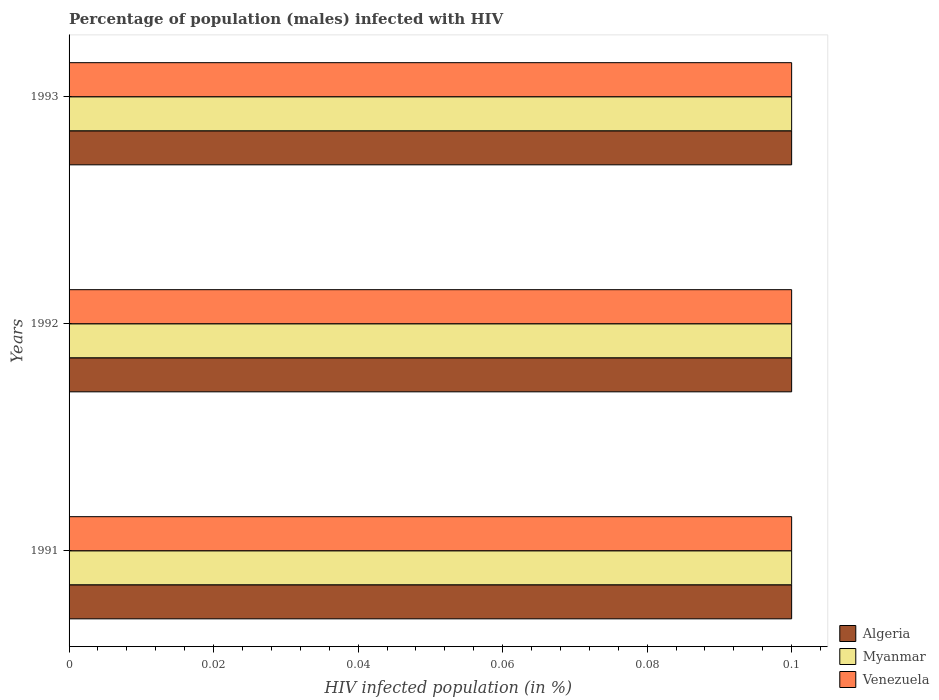How many groups of bars are there?
Your response must be concise. 3. How many bars are there on the 2nd tick from the top?
Provide a short and direct response. 3. How many bars are there on the 3rd tick from the bottom?
Give a very brief answer. 3. What is the percentage of HIV infected male population in Algeria in 1993?
Provide a succinct answer. 0.1. Across all years, what is the maximum percentage of HIV infected male population in Myanmar?
Offer a very short reply. 0.1. Across all years, what is the minimum percentage of HIV infected male population in Venezuela?
Offer a very short reply. 0.1. In which year was the percentage of HIV infected male population in Myanmar minimum?
Provide a short and direct response. 1991. What is the total percentage of HIV infected male population in Venezuela in the graph?
Offer a terse response. 0.3. What is the difference between the percentage of HIV infected male population in Myanmar in 1991 and that in 1993?
Offer a terse response. 0. What is the average percentage of HIV infected male population in Algeria per year?
Offer a terse response. 0.1. In the year 1992, what is the difference between the percentage of HIV infected male population in Myanmar and percentage of HIV infected male population in Algeria?
Provide a short and direct response. 0. In how many years, is the percentage of HIV infected male population in Algeria greater than 0.076 %?
Provide a short and direct response. 3. What is the ratio of the percentage of HIV infected male population in Venezuela in 1991 to that in 1993?
Make the answer very short. 1. What is the difference between the highest and the lowest percentage of HIV infected male population in Venezuela?
Give a very brief answer. 0. In how many years, is the percentage of HIV infected male population in Venezuela greater than the average percentage of HIV infected male population in Venezuela taken over all years?
Provide a short and direct response. 0. What does the 3rd bar from the top in 1993 represents?
Provide a short and direct response. Algeria. What does the 1st bar from the bottom in 1991 represents?
Offer a very short reply. Algeria. Is it the case that in every year, the sum of the percentage of HIV infected male population in Myanmar and percentage of HIV infected male population in Venezuela is greater than the percentage of HIV infected male population in Algeria?
Offer a very short reply. Yes. How many bars are there?
Give a very brief answer. 9. How many years are there in the graph?
Make the answer very short. 3. What is the difference between two consecutive major ticks on the X-axis?
Keep it short and to the point. 0.02. Where does the legend appear in the graph?
Give a very brief answer. Bottom right. How are the legend labels stacked?
Offer a terse response. Vertical. What is the title of the graph?
Your answer should be very brief. Percentage of population (males) infected with HIV. Does "Pacific island small states" appear as one of the legend labels in the graph?
Your answer should be compact. No. What is the label or title of the X-axis?
Your answer should be compact. HIV infected population (in %). What is the label or title of the Y-axis?
Provide a short and direct response. Years. What is the HIV infected population (in %) in Myanmar in 1991?
Provide a succinct answer. 0.1. What is the HIV infected population (in %) of Venezuela in 1991?
Your answer should be compact. 0.1. What is the HIV infected population (in %) in Algeria in 1992?
Make the answer very short. 0.1. What is the HIV infected population (in %) of Myanmar in 1992?
Your response must be concise. 0.1. What is the HIV infected population (in %) of Venezuela in 1992?
Ensure brevity in your answer.  0.1. What is the HIV infected population (in %) in Venezuela in 1993?
Give a very brief answer. 0.1. Across all years, what is the maximum HIV infected population (in %) of Venezuela?
Offer a very short reply. 0.1. Across all years, what is the minimum HIV infected population (in %) in Algeria?
Your answer should be very brief. 0.1. Across all years, what is the minimum HIV infected population (in %) of Venezuela?
Your answer should be very brief. 0.1. What is the total HIV infected population (in %) of Myanmar in the graph?
Your response must be concise. 0.3. What is the total HIV infected population (in %) of Venezuela in the graph?
Provide a succinct answer. 0.3. What is the difference between the HIV infected population (in %) in Myanmar in 1991 and that in 1992?
Your answer should be compact. 0. What is the difference between the HIV infected population (in %) of Venezuela in 1991 and that in 1992?
Offer a very short reply. 0. What is the difference between the HIV infected population (in %) in Myanmar in 1991 and that in 1993?
Provide a succinct answer. 0. What is the difference between the HIV infected population (in %) of Myanmar in 1992 and that in 1993?
Your answer should be very brief. 0. What is the difference between the HIV infected population (in %) of Algeria in 1991 and the HIV infected population (in %) of Venezuela in 1992?
Your answer should be very brief. 0. What is the difference between the HIV infected population (in %) of Myanmar in 1991 and the HIV infected population (in %) of Venezuela in 1992?
Keep it short and to the point. 0. What is the difference between the HIV infected population (in %) of Algeria in 1992 and the HIV infected population (in %) of Myanmar in 1993?
Your response must be concise. 0. What is the difference between the HIV infected population (in %) of Algeria in 1992 and the HIV infected population (in %) of Venezuela in 1993?
Your response must be concise. 0. What is the average HIV infected population (in %) of Venezuela per year?
Your answer should be compact. 0.1. In the year 1991, what is the difference between the HIV infected population (in %) in Algeria and HIV infected population (in %) in Venezuela?
Make the answer very short. 0. In the year 1991, what is the difference between the HIV infected population (in %) of Myanmar and HIV infected population (in %) of Venezuela?
Ensure brevity in your answer.  0. In the year 1992, what is the difference between the HIV infected population (in %) in Algeria and HIV infected population (in %) in Venezuela?
Give a very brief answer. 0. In the year 1993, what is the difference between the HIV infected population (in %) in Algeria and HIV infected population (in %) in Myanmar?
Your response must be concise. 0. In the year 1993, what is the difference between the HIV infected population (in %) in Algeria and HIV infected population (in %) in Venezuela?
Offer a terse response. 0. In the year 1993, what is the difference between the HIV infected population (in %) in Myanmar and HIV infected population (in %) in Venezuela?
Keep it short and to the point. 0. What is the ratio of the HIV infected population (in %) of Algeria in 1991 to that in 1992?
Provide a succinct answer. 1. What is the ratio of the HIV infected population (in %) in Myanmar in 1991 to that in 1992?
Offer a terse response. 1. What is the ratio of the HIV infected population (in %) in Algeria in 1991 to that in 1993?
Ensure brevity in your answer.  1. What is the ratio of the HIV infected population (in %) in Myanmar in 1991 to that in 1993?
Your answer should be very brief. 1. What is the ratio of the HIV infected population (in %) of Algeria in 1992 to that in 1993?
Provide a succinct answer. 1. What is the ratio of the HIV infected population (in %) in Myanmar in 1992 to that in 1993?
Make the answer very short. 1. What is the difference between the highest and the second highest HIV infected population (in %) of Venezuela?
Make the answer very short. 0. What is the difference between the highest and the lowest HIV infected population (in %) of Myanmar?
Provide a succinct answer. 0. What is the difference between the highest and the lowest HIV infected population (in %) of Venezuela?
Keep it short and to the point. 0. 